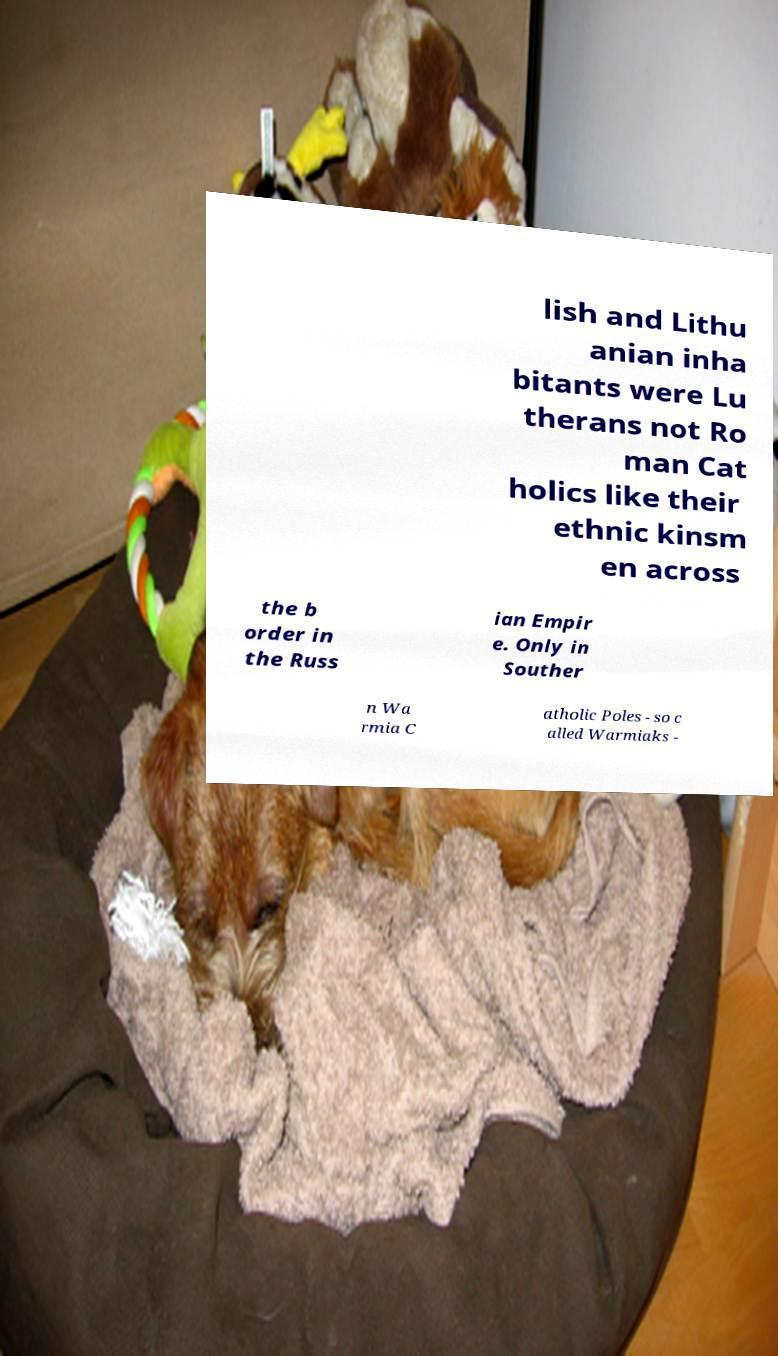I need the written content from this picture converted into text. Can you do that? lish and Lithu anian inha bitants were Lu therans not Ro man Cat holics like their ethnic kinsm en across the b order in the Russ ian Empir e. Only in Souther n Wa rmia C atholic Poles - so c alled Warmiaks - 